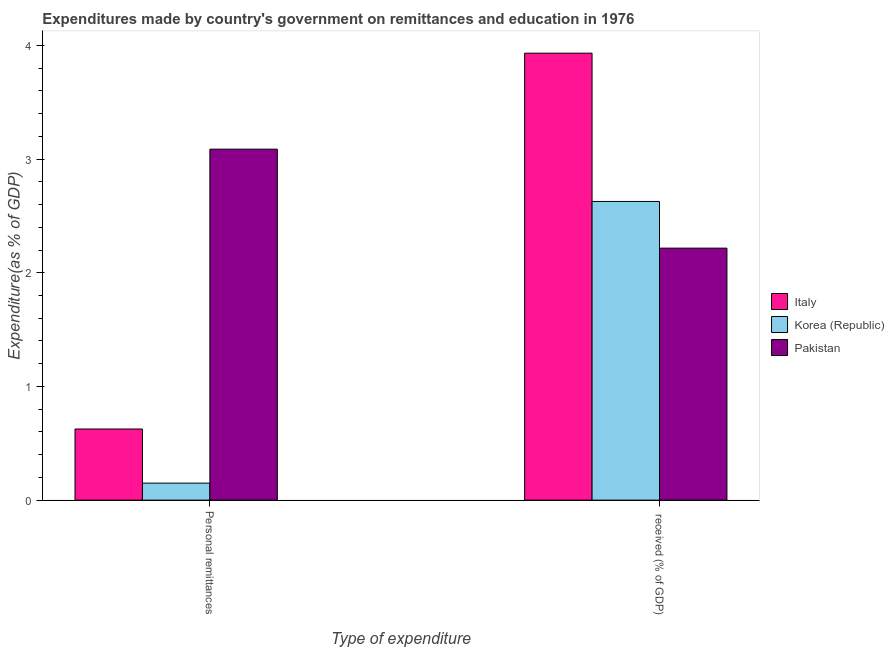Are the number of bars per tick equal to the number of legend labels?
Offer a very short reply. Yes. How many bars are there on the 1st tick from the left?
Offer a terse response. 3. How many bars are there on the 2nd tick from the right?
Provide a succinct answer. 3. What is the label of the 1st group of bars from the left?
Your answer should be very brief. Personal remittances. What is the expenditure in personal remittances in Italy?
Offer a terse response. 0.63. Across all countries, what is the maximum expenditure in personal remittances?
Your response must be concise. 3.09. Across all countries, what is the minimum expenditure in education?
Offer a terse response. 2.22. In which country was the expenditure in education maximum?
Provide a succinct answer. Italy. What is the total expenditure in personal remittances in the graph?
Make the answer very short. 3.86. What is the difference between the expenditure in education in Pakistan and that in Korea (Republic)?
Provide a short and direct response. -0.41. What is the difference between the expenditure in personal remittances in Italy and the expenditure in education in Pakistan?
Keep it short and to the point. -1.59. What is the average expenditure in education per country?
Your response must be concise. 2.92. What is the difference between the expenditure in personal remittances and expenditure in education in Pakistan?
Keep it short and to the point. 0.87. What is the ratio of the expenditure in personal remittances in Pakistan to that in Italy?
Make the answer very short. 4.93. Is the expenditure in education in Italy less than that in Pakistan?
Keep it short and to the point. No. In how many countries, is the expenditure in personal remittances greater than the average expenditure in personal remittances taken over all countries?
Offer a very short reply. 1. What does the 2nd bar from the left in  received (% of GDP) represents?
Give a very brief answer. Korea (Republic). How many bars are there?
Your response must be concise. 6. Are the values on the major ticks of Y-axis written in scientific E-notation?
Your answer should be compact. No. Where does the legend appear in the graph?
Make the answer very short. Center right. How many legend labels are there?
Provide a succinct answer. 3. How are the legend labels stacked?
Your response must be concise. Vertical. What is the title of the graph?
Ensure brevity in your answer.  Expenditures made by country's government on remittances and education in 1976. Does "Northern Mariana Islands" appear as one of the legend labels in the graph?
Provide a succinct answer. No. What is the label or title of the X-axis?
Your answer should be compact. Type of expenditure. What is the label or title of the Y-axis?
Provide a short and direct response. Expenditure(as % of GDP). What is the Expenditure(as % of GDP) in Italy in Personal remittances?
Ensure brevity in your answer.  0.63. What is the Expenditure(as % of GDP) of Korea (Republic) in Personal remittances?
Ensure brevity in your answer.  0.15. What is the Expenditure(as % of GDP) in Pakistan in Personal remittances?
Your response must be concise. 3.09. What is the Expenditure(as % of GDP) in Italy in  received (% of GDP)?
Make the answer very short. 3.93. What is the Expenditure(as % of GDP) of Korea (Republic) in  received (% of GDP)?
Keep it short and to the point. 2.63. What is the Expenditure(as % of GDP) in Pakistan in  received (% of GDP)?
Offer a very short reply. 2.22. Across all Type of expenditure, what is the maximum Expenditure(as % of GDP) of Italy?
Provide a short and direct response. 3.93. Across all Type of expenditure, what is the maximum Expenditure(as % of GDP) in Korea (Republic)?
Offer a terse response. 2.63. Across all Type of expenditure, what is the maximum Expenditure(as % of GDP) in Pakistan?
Your response must be concise. 3.09. Across all Type of expenditure, what is the minimum Expenditure(as % of GDP) of Italy?
Offer a terse response. 0.63. Across all Type of expenditure, what is the minimum Expenditure(as % of GDP) in Korea (Republic)?
Ensure brevity in your answer.  0.15. Across all Type of expenditure, what is the minimum Expenditure(as % of GDP) of Pakistan?
Provide a succinct answer. 2.22. What is the total Expenditure(as % of GDP) of Italy in the graph?
Your response must be concise. 4.56. What is the total Expenditure(as % of GDP) of Korea (Republic) in the graph?
Ensure brevity in your answer.  2.78. What is the total Expenditure(as % of GDP) in Pakistan in the graph?
Your answer should be very brief. 5.3. What is the difference between the Expenditure(as % of GDP) in Italy in Personal remittances and that in  received (% of GDP)?
Offer a very short reply. -3.31. What is the difference between the Expenditure(as % of GDP) in Korea (Republic) in Personal remittances and that in  received (% of GDP)?
Keep it short and to the point. -2.48. What is the difference between the Expenditure(as % of GDP) of Pakistan in Personal remittances and that in  received (% of GDP)?
Make the answer very short. 0.87. What is the difference between the Expenditure(as % of GDP) in Italy in Personal remittances and the Expenditure(as % of GDP) in Korea (Republic) in  received (% of GDP)?
Your answer should be compact. -2. What is the difference between the Expenditure(as % of GDP) of Italy in Personal remittances and the Expenditure(as % of GDP) of Pakistan in  received (% of GDP)?
Your answer should be compact. -1.59. What is the difference between the Expenditure(as % of GDP) in Korea (Republic) in Personal remittances and the Expenditure(as % of GDP) in Pakistan in  received (% of GDP)?
Provide a short and direct response. -2.07. What is the average Expenditure(as % of GDP) in Italy per Type of expenditure?
Your answer should be very brief. 2.28. What is the average Expenditure(as % of GDP) of Korea (Republic) per Type of expenditure?
Offer a terse response. 1.39. What is the average Expenditure(as % of GDP) of Pakistan per Type of expenditure?
Provide a short and direct response. 2.65. What is the difference between the Expenditure(as % of GDP) of Italy and Expenditure(as % of GDP) of Korea (Republic) in Personal remittances?
Provide a succinct answer. 0.48. What is the difference between the Expenditure(as % of GDP) in Italy and Expenditure(as % of GDP) in Pakistan in Personal remittances?
Offer a very short reply. -2.46. What is the difference between the Expenditure(as % of GDP) of Korea (Republic) and Expenditure(as % of GDP) of Pakistan in Personal remittances?
Your answer should be compact. -2.94. What is the difference between the Expenditure(as % of GDP) in Italy and Expenditure(as % of GDP) in Korea (Republic) in  received (% of GDP)?
Give a very brief answer. 1.3. What is the difference between the Expenditure(as % of GDP) of Italy and Expenditure(as % of GDP) of Pakistan in  received (% of GDP)?
Your answer should be very brief. 1.71. What is the difference between the Expenditure(as % of GDP) in Korea (Republic) and Expenditure(as % of GDP) in Pakistan in  received (% of GDP)?
Provide a short and direct response. 0.41. What is the ratio of the Expenditure(as % of GDP) in Italy in Personal remittances to that in  received (% of GDP)?
Give a very brief answer. 0.16. What is the ratio of the Expenditure(as % of GDP) of Korea (Republic) in Personal remittances to that in  received (% of GDP)?
Your response must be concise. 0.06. What is the ratio of the Expenditure(as % of GDP) in Pakistan in Personal remittances to that in  received (% of GDP)?
Provide a succinct answer. 1.39. What is the difference between the highest and the second highest Expenditure(as % of GDP) in Italy?
Offer a terse response. 3.31. What is the difference between the highest and the second highest Expenditure(as % of GDP) of Korea (Republic)?
Offer a terse response. 2.48. What is the difference between the highest and the second highest Expenditure(as % of GDP) in Pakistan?
Keep it short and to the point. 0.87. What is the difference between the highest and the lowest Expenditure(as % of GDP) of Italy?
Your answer should be compact. 3.31. What is the difference between the highest and the lowest Expenditure(as % of GDP) of Korea (Republic)?
Give a very brief answer. 2.48. What is the difference between the highest and the lowest Expenditure(as % of GDP) of Pakistan?
Keep it short and to the point. 0.87. 